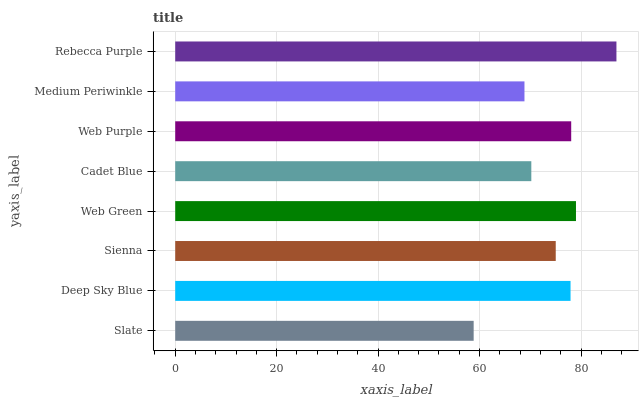Is Slate the minimum?
Answer yes or no. Yes. Is Rebecca Purple the maximum?
Answer yes or no. Yes. Is Deep Sky Blue the minimum?
Answer yes or no. No. Is Deep Sky Blue the maximum?
Answer yes or no. No. Is Deep Sky Blue greater than Slate?
Answer yes or no. Yes. Is Slate less than Deep Sky Blue?
Answer yes or no. Yes. Is Slate greater than Deep Sky Blue?
Answer yes or no. No. Is Deep Sky Blue less than Slate?
Answer yes or no. No. Is Deep Sky Blue the high median?
Answer yes or no. Yes. Is Sienna the low median?
Answer yes or no. Yes. Is Web Purple the high median?
Answer yes or no. No. Is Deep Sky Blue the low median?
Answer yes or no. No. 